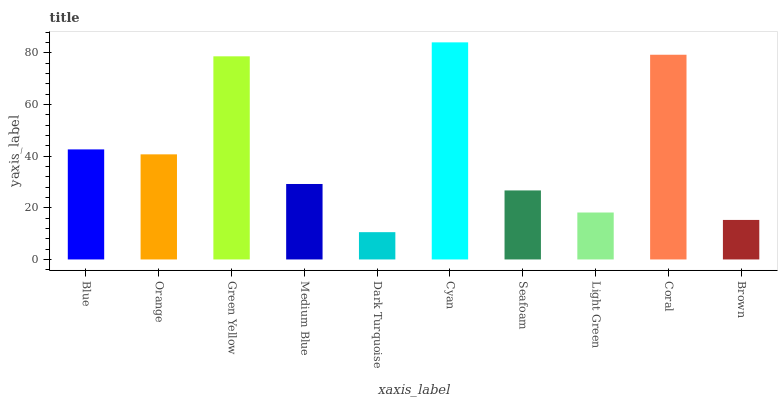Is Dark Turquoise the minimum?
Answer yes or no. Yes. Is Cyan the maximum?
Answer yes or no. Yes. Is Orange the minimum?
Answer yes or no. No. Is Orange the maximum?
Answer yes or no. No. Is Blue greater than Orange?
Answer yes or no. Yes. Is Orange less than Blue?
Answer yes or no. Yes. Is Orange greater than Blue?
Answer yes or no. No. Is Blue less than Orange?
Answer yes or no. No. Is Orange the high median?
Answer yes or no. Yes. Is Medium Blue the low median?
Answer yes or no. Yes. Is Dark Turquoise the high median?
Answer yes or no. No. Is Dark Turquoise the low median?
Answer yes or no. No. 